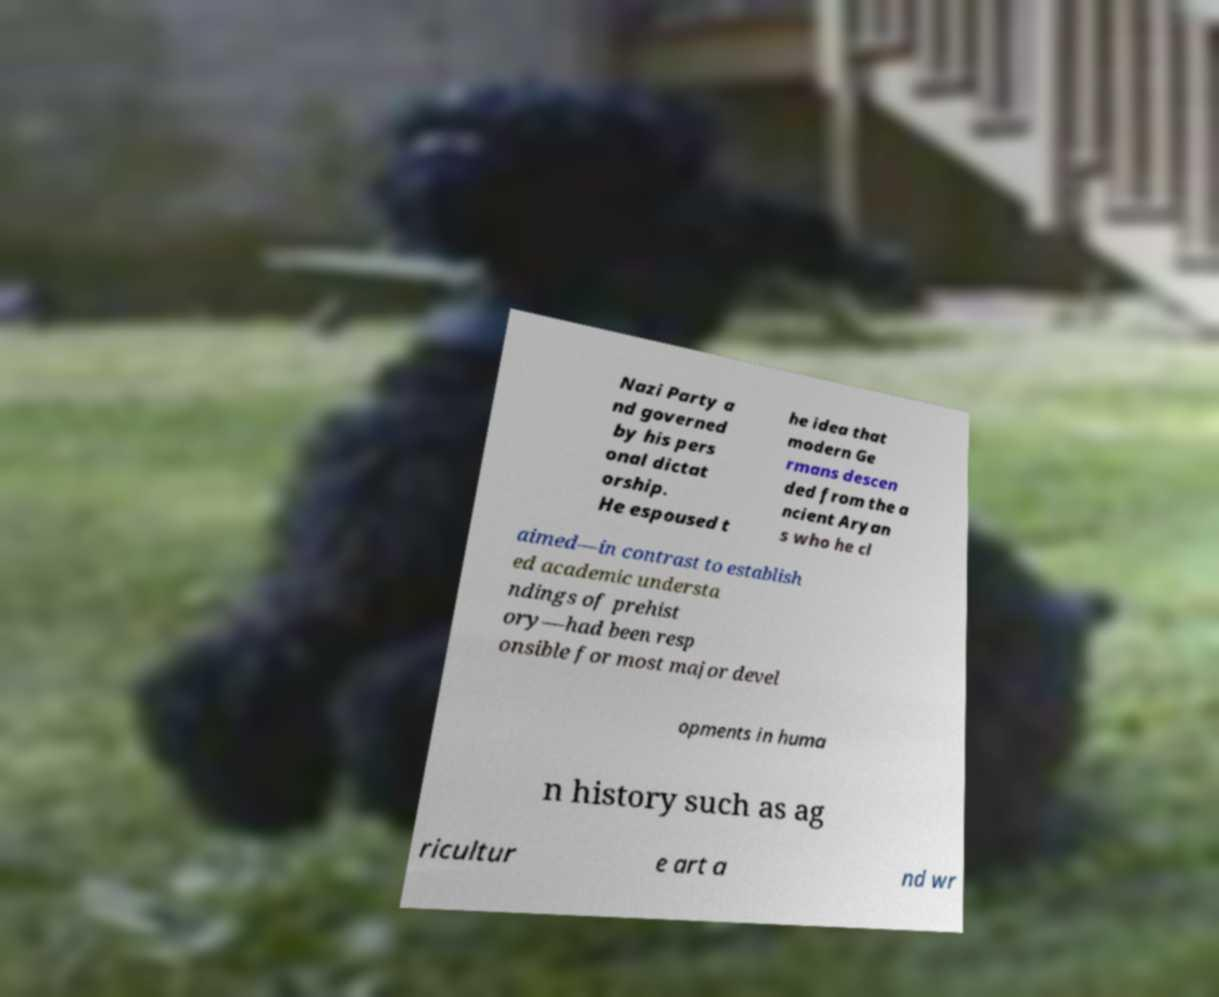Please read and relay the text visible in this image. What does it say? Nazi Party a nd governed by his pers onal dictat orship. He espoused t he idea that modern Ge rmans descen ded from the a ncient Aryan s who he cl aimed—in contrast to establish ed academic understa ndings of prehist ory—had been resp onsible for most major devel opments in huma n history such as ag ricultur e art a nd wr 